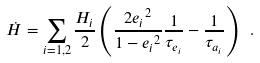Convert formula to latex. <formula><loc_0><loc_0><loc_500><loc_500>\dot { H } = \sum _ { i = 1 , 2 } \frac { H _ { i } } { 2 } \left ( \frac { 2 { e _ { i } } ^ { 2 } } { 1 - { e _ { i } } ^ { 2 } } \frac { 1 } { \tau _ { e _ { i } } } - \frac { 1 } { \tau _ { a _ { i } } } \right ) \ .</formula> 